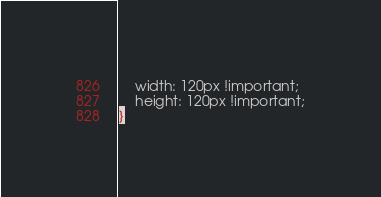Convert code to text. <code><loc_0><loc_0><loc_500><loc_500><_CSS_>	width: 120px !important;
	height: 120px !important;
}</code> 